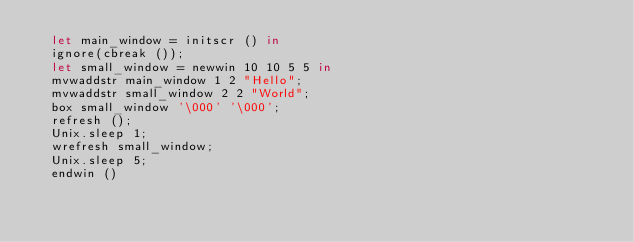<code> <loc_0><loc_0><loc_500><loc_500><_OCaml_>  let main_window = initscr () in
  ignore(cbreak ());
  let small_window = newwin 10 10 5 5 in
  mvwaddstr main_window 1 2 "Hello";
  mvwaddstr small_window 2 2 "World";
  box small_window '\000' '\000';
  refresh ();
  Unix.sleep 1;
  wrefresh small_window;
  Unix.sleep 5;
  endwin ()
</code> 